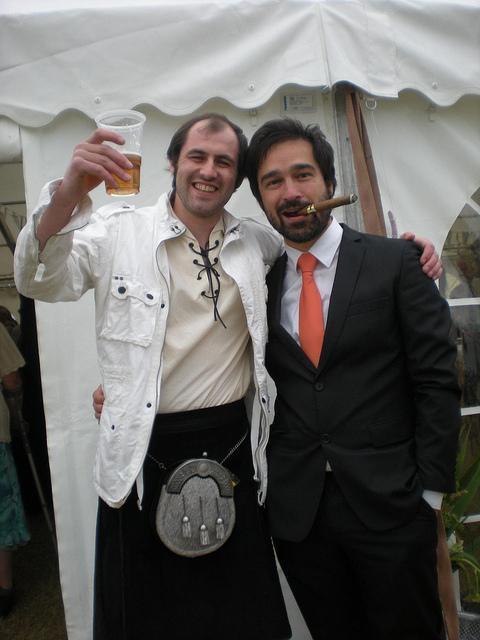How many medals does the person have?
Give a very brief answer. 1. How many people are there?
Give a very brief answer. 3. How many ski poles are there?
Give a very brief answer. 0. 